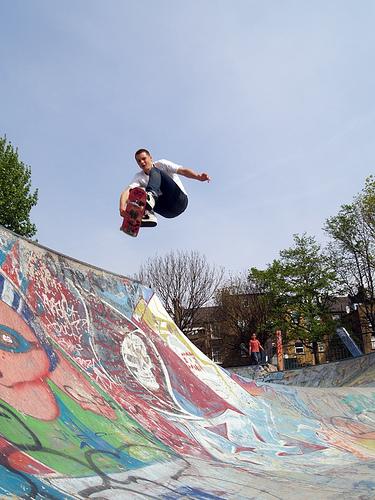What is the man doing?
Write a very short answer. Skateboarding. What type of art is shown?
Write a very short answer. Graffiti. Is the man on the ground?
Write a very short answer. No. 